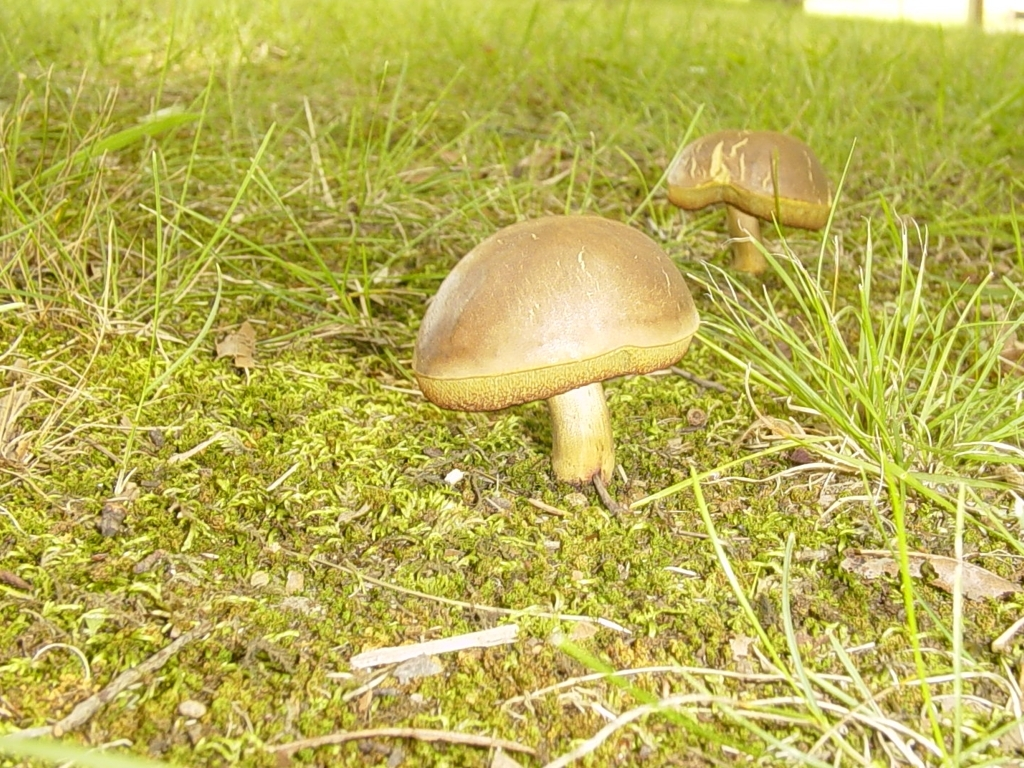What can be said about the focus in the photo?
A. unfocused
B. successful
C. blurry
D. out of focus
Answer with the option's letter from the given choices directly.
 B. 